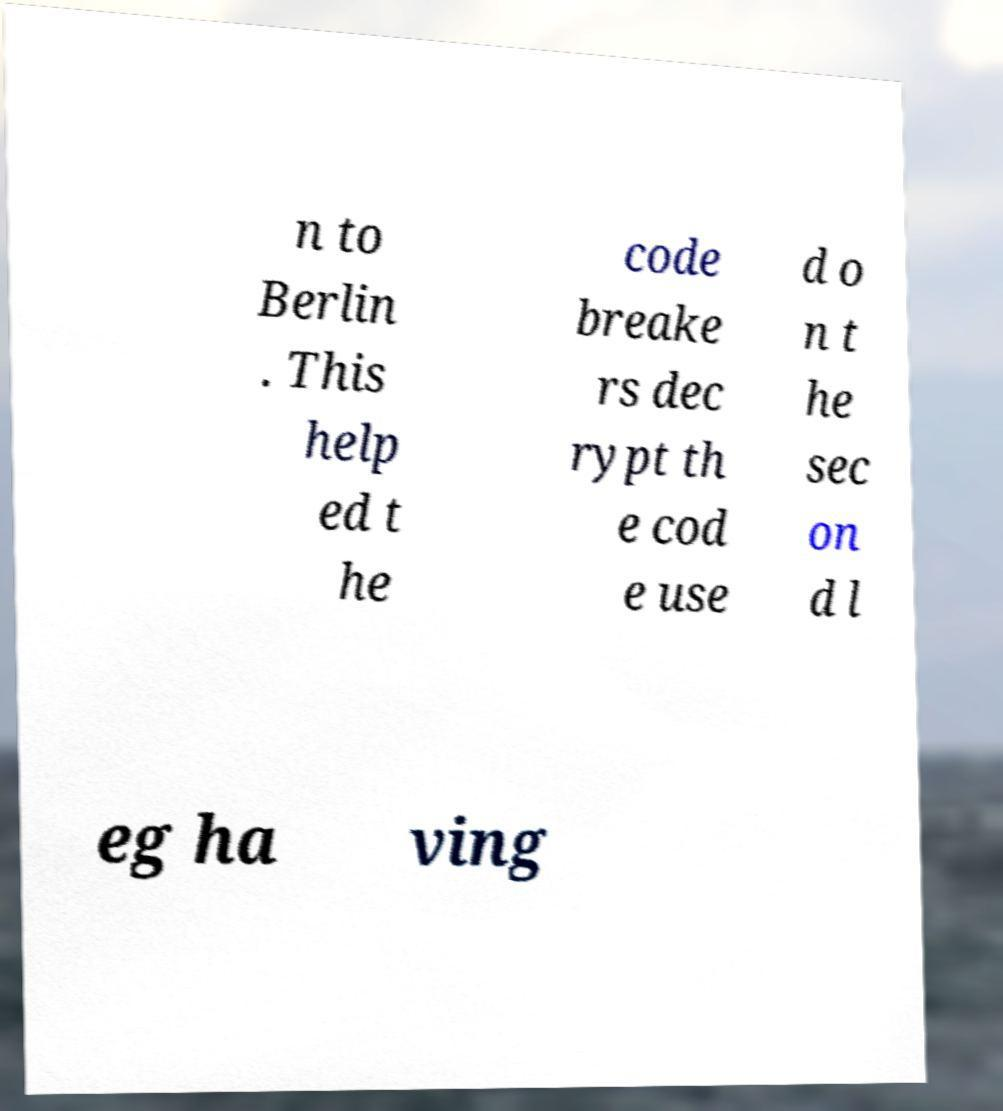What messages or text are displayed in this image? I need them in a readable, typed format. n to Berlin . This help ed t he code breake rs dec rypt th e cod e use d o n t he sec on d l eg ha ving 